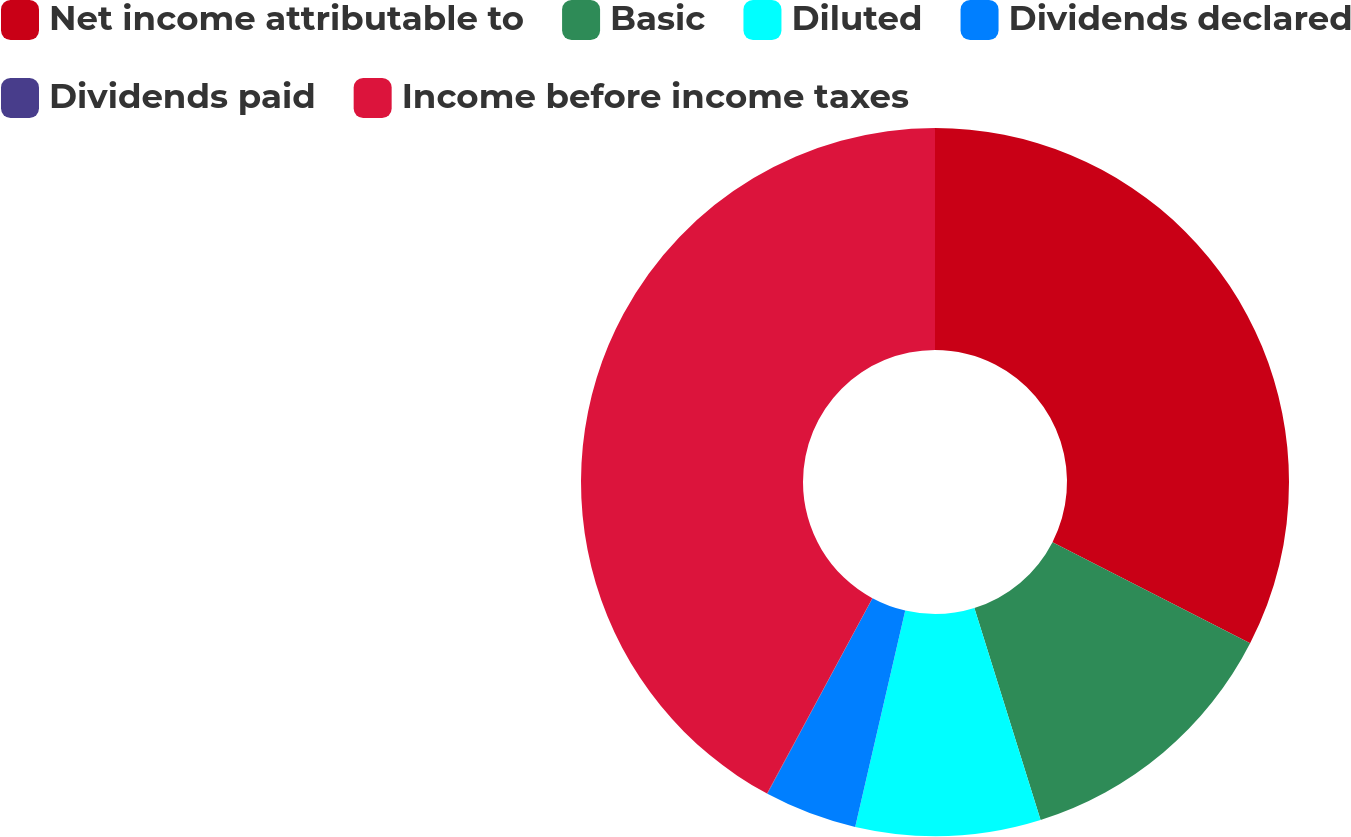<chart> <loc_0><loc_0><loc_500><loc_500><pie_chart><fcel>Net income attributable to<fcel>Basic<fcel>Diluted<fcel>Dividends declared<fcel>Dividends paid<fcel>Income before income taxes<nl><fcel>32.53%<fcel>12.65%<fcel>8.44%<fcel>4.23%<fcel>0.02%<fcel>42.13%<nl></chart> 